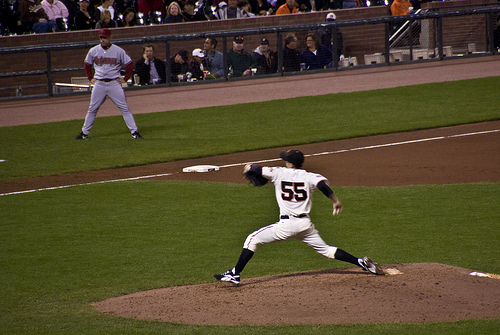What is the color of the fence? The fence is black, providing a stark background against the vibrant green grass and the players' uniforms. 